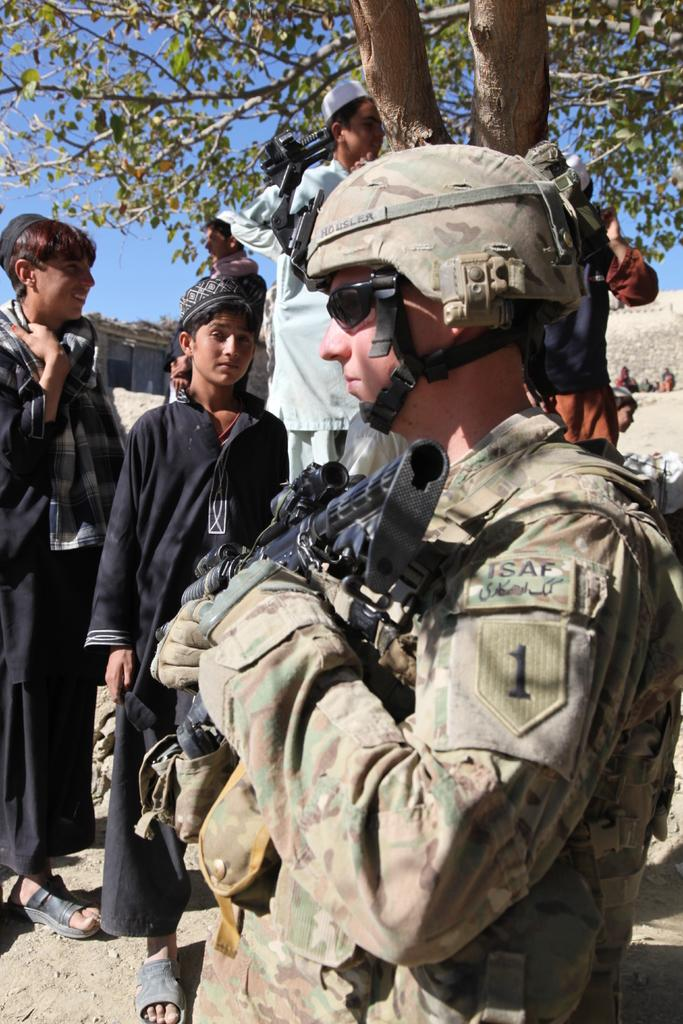How many people are in the image? There is a group of people in the image, but the exact number is not specified. What are the people doing in the image? The people are standing on the ground in the image. What objects can be seen in the image that are related to the people? There are guns in the image. What type of natural element is present in the image? There is a tree in the image. What can be seen in the background of the image? The sky is visible in the background of the image. What type of pipe can be seen in the image? There is no pipe present in the image. What message of hope can be seen in the image? There is no message of hope or any text visible in the image. 